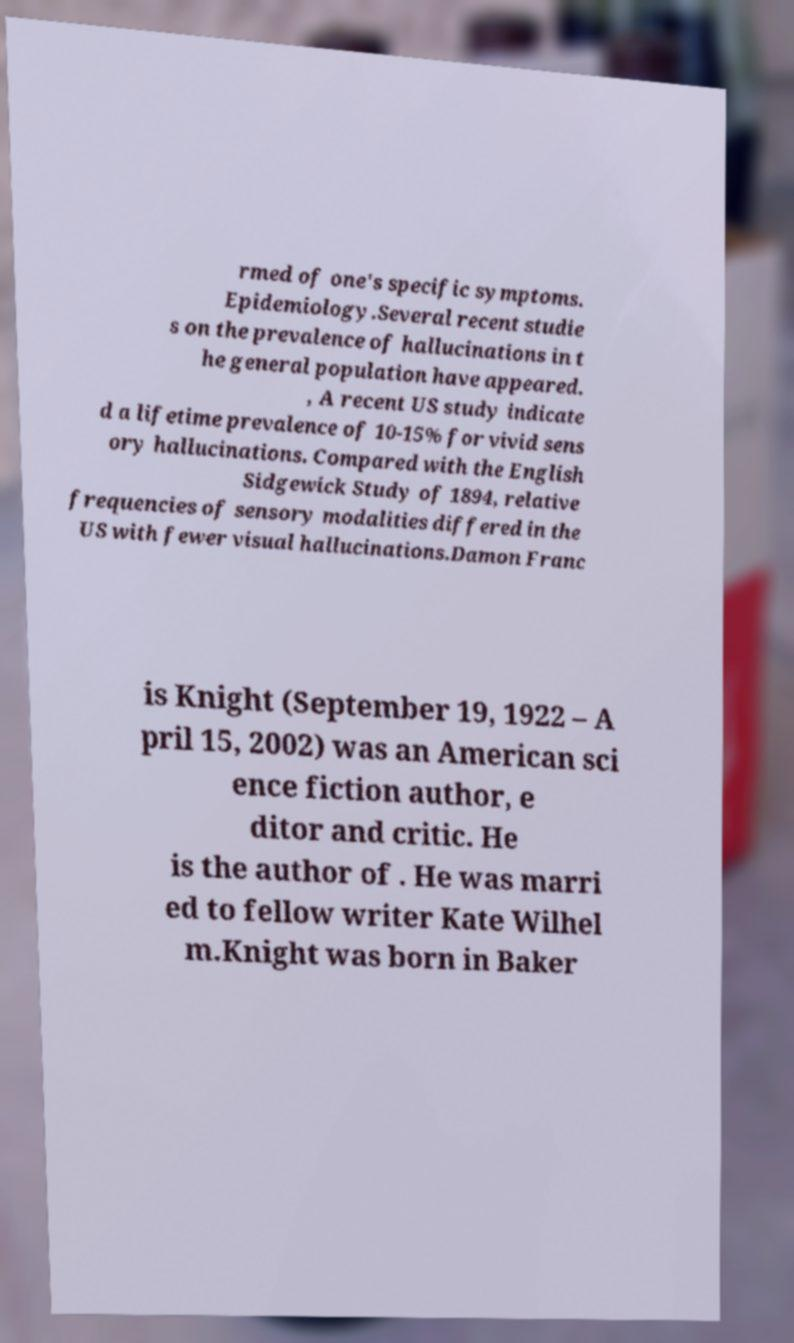Can you accurately transcribe the text from the provided image for me? rmed of one's specific symptoms. Epidemiology.Several recent studie s on the prevalence of hallucinations in t he general population have appeared. , A recent US study indicate d a lifetime prevalence of 10-15% for vivid sens ory hallucinations. Compared with the English Sidgewick Study of 1894, relative frequencies of sensory modalities differed in the US with fewer visual hallucinations.Damon Franc is Knight (September 19, 1922 – A pril 15, 2002) was an American sci ence fiction author, e ditor and critic. He is the author of . He was marri ed to fellow writer Kate Wilhel m.Knight was born in Baker 